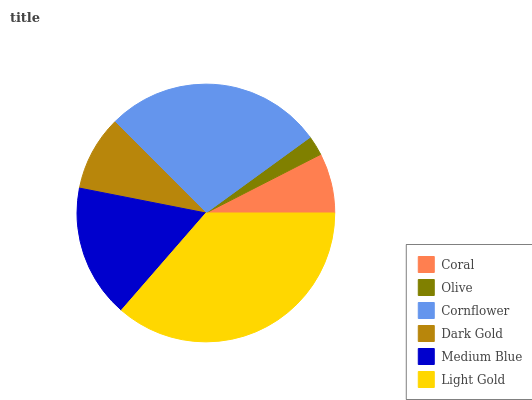Is Olive the minimum?
Answer yes or no. Yes. Is Light Gold the maximum?
Answer yes or no. Yes. Is Cornflower the minimum?
Answer yes or no. No. Is Cornflower the maximum?
Answer yes or no. No. Is Cornflower greater than Olive?
Answer yes or no. Yes. Is Olive less than Cornflower?
Answer yes or no. Yes. Is Olive greater than Cornflower?
Answer yes or no. No. Is Cornflower less than Olive?
Answer yes or no. No. Is Medium Blue the high median?
Answer yes or no. Yes. Is Dark Gold the low median?
Answer yes or no. Yes. Is Coral the high median?
Answer yes or no. No. Is Medium Blue the low median?
Answer yes or no. No. 